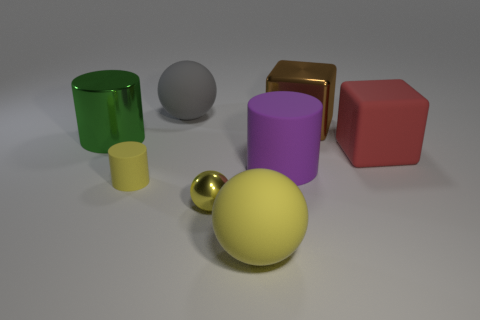Add 2 large red matte objects. How many objects exist? 10 Subtract all blocks. How many objects are left? 6 Add 3 small rubber cubes. How many small rubber cubes exist? 3 Subtract 0 green blocks. How many objects are left? 8 Subtract all red metal cylinders. Subtract all red matte objects. How many objects are left? 7 Add 4 large cylinders. How many large cylinders are left? 6 